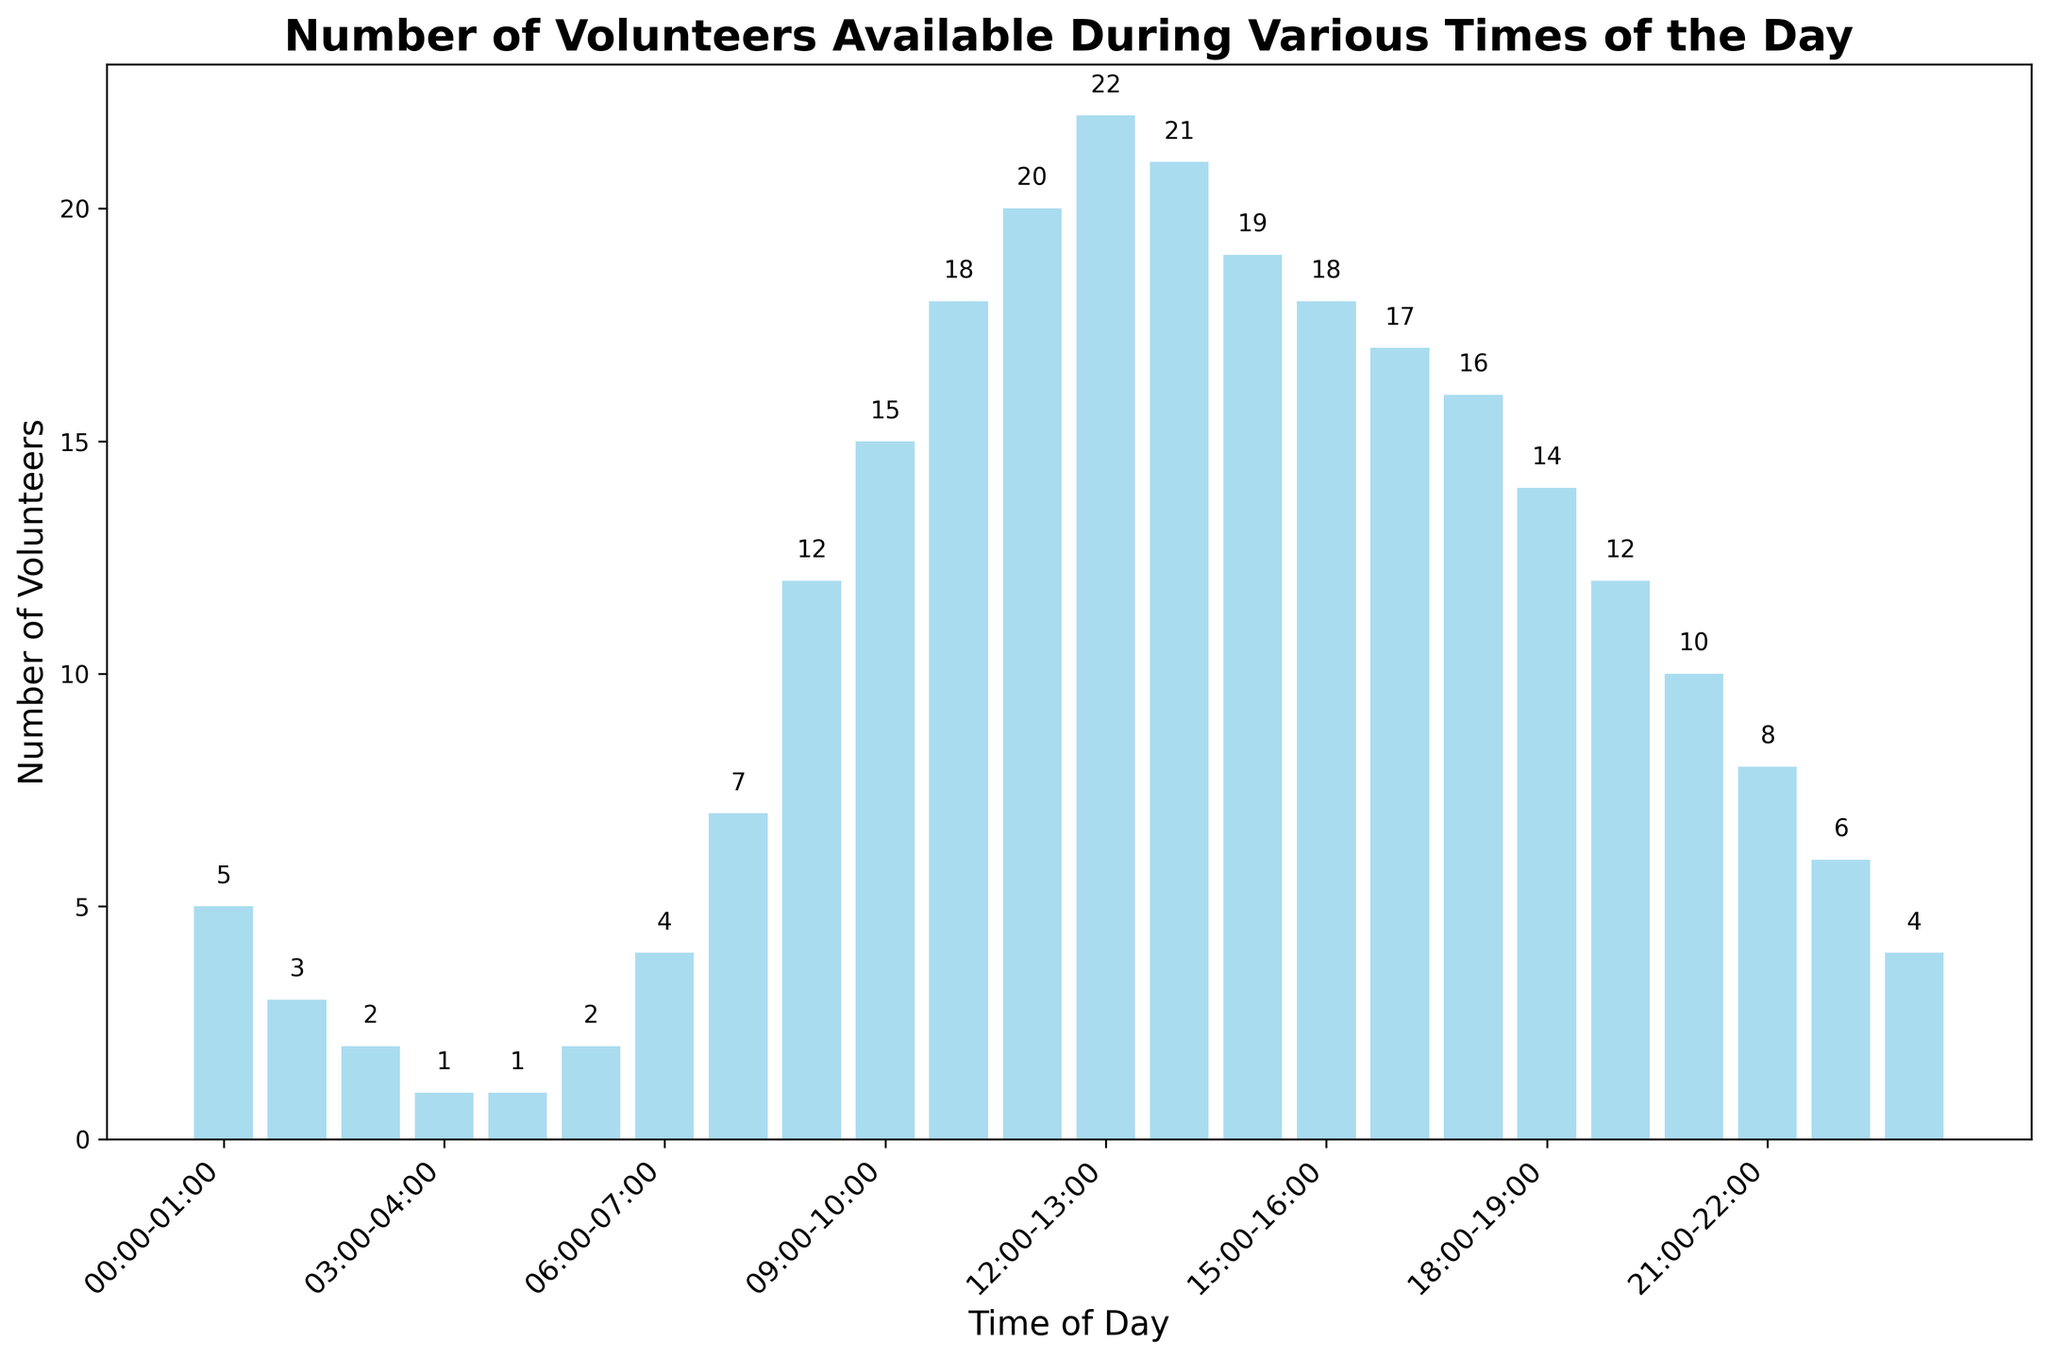What is the total number of volunteers available between 01:00 and 05:00? Add the number of volunteers available from 01:00-02:00, 02:00-03:00, 03:00-04:00, and 04:00-05:00: 3 + 2 + 1 + 1 = 7
Answer: 7 Which time of day has the highest number of volunteers? Find the time interval with the tallest bar in the chart. The time interval 12:00-13:00 has 22 volunteers, the highest number.
Answer: 12:00-13:00 What is the difference in the number of volunteers between 10:00-11:00 and 18:00-19:00? Subtract the number of volunteers at 18:00-19:00 from the number at 10:00-11:00: 18 - 14 = 4
Answer: 4 How many more volunteers are there at 12:00-13:00 compared to 00:00-01:00? Subtract the number of volunteers at 00:00-01:00 from the number at 12:00-13:00: 22 - 5 = 17
Answer: 17 What is the average number of volunteers available between 09:00 and 13:00? Calculate the sum of volunteers from 09:00-10:00, 10:00-11:00, 11:00-12:00, and 12:00-13:00, then divide by 4: (15 + 18 + 20 + 22) / 4 = 75 / 4 = 18.75
Answer: 18.75 Is the number of volunteers at 08:00-09:00 greater than the number of volunteers at 19:00-20:00? Compare the number of volunteers at 08:00-09:00 (12) to 19:00-20:00 (12). Both are equal.
Answer: No Is there a time of day when exactly 10 volunteers were available? Check the chart for a bar labeled with 10: the time interval 20:00-21:00 has 10 volunteers.
Answer: Yes What is the least number of volunteers available at any time during the day? Identify the shortest bar in the chart, which is at both 03:00-04:00 and 04:00-05:00 with 1 volunteer.
Answer: 1 